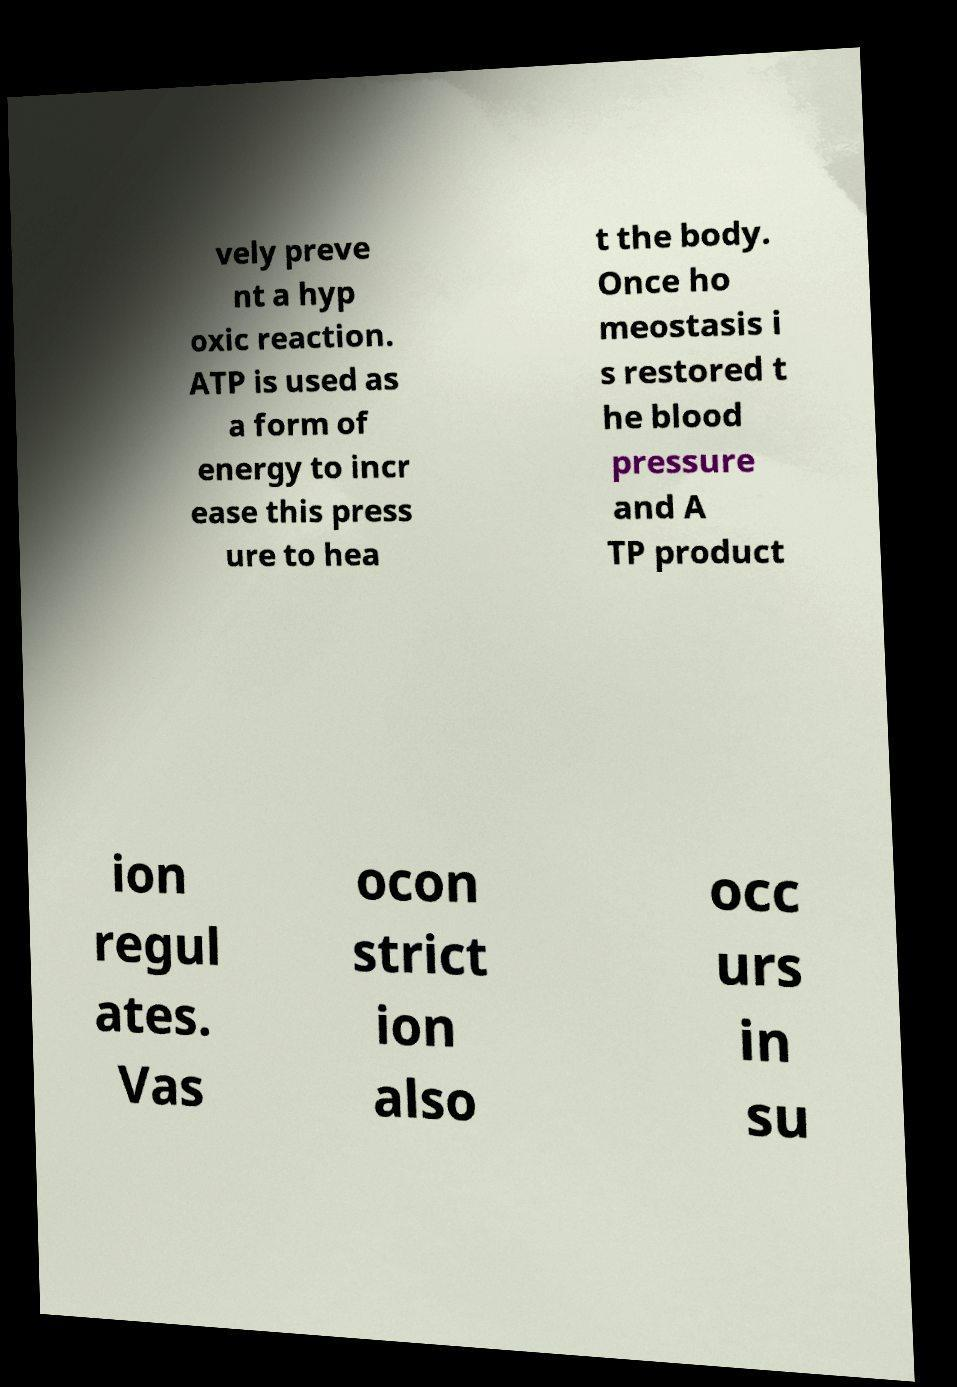Can you accurately transcribe the text from the provided image for me? vely preve nt a hyp oxic reaction. ATP is used as a form of energy to incr ease this press ure to hea t the body. Once ho meostasis i s restored t he blood pressure and A TP product ion regul ates. Vas ocon strict ion also occ urs in su 